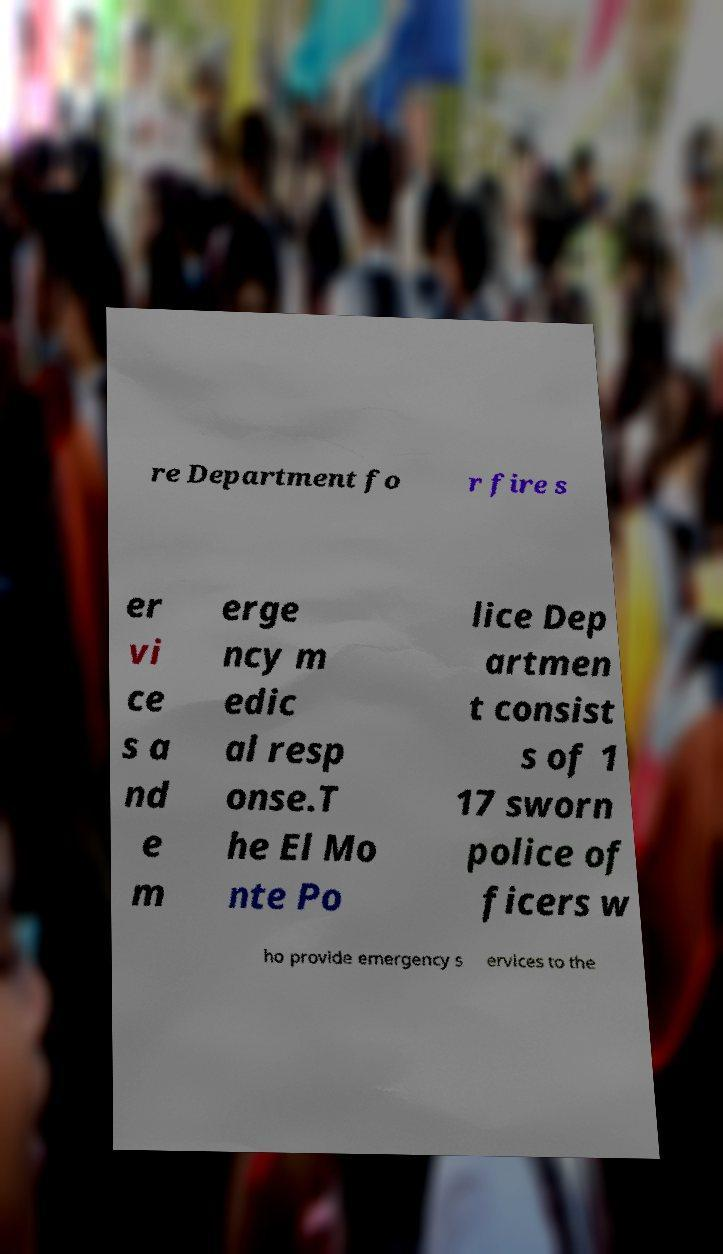I need the written content from this picture converted into text. Can you do that? re Department fo r fire s er vi ce s a nd e m erge ncy m edic al resp onse.T he El Mo nte Po lice Dep artmen t consist s of 1 17 sworn police of ficers w ho provide emergency s ervices to the 